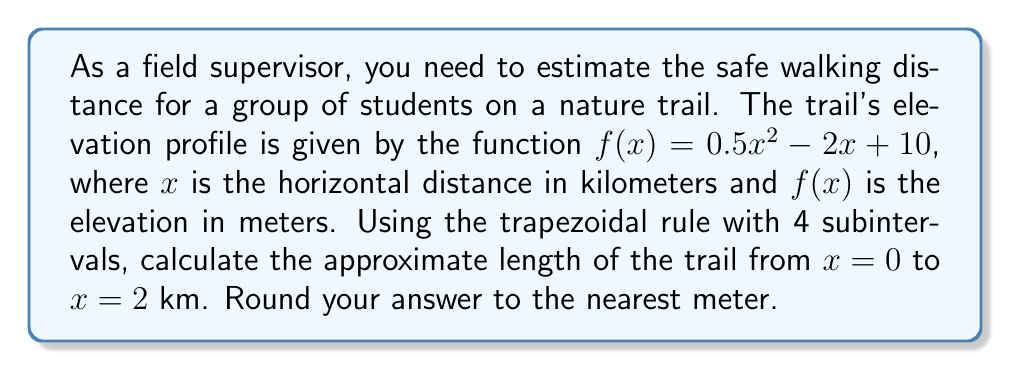Can you answer this question? To solve this problem, we'll use the trapezoidal rule for numerical integration to approximate the arc length of the trail. The steps are as follows:

1) The formula for arc length is:

   $$L = \int_a^b \sqrt{1 + [f'(x)]^2} dx$$

2) First, we need to find $f'(x)$:
   
   $$f'(x) = x - 2$$

3) Now, our integrand is:

   $$\sqrt{1 + (x - 2)^2}$$

4) We'll use the trapezoidal rule with 4 subintervals. The formula is:

   $$\int_a^b f(x)dx \approx \frac{h}{2}[f(x_0) + 2f(x_1) + 2f(x_2) + 2f(x_3) + f(x_4)]$$

   where $h = \frac{b-a}{n}$, and $n$ is the number of subintervals.

5) In our case, $a = 0$, $b = 2$, and $n = 4$. So, $h = \frac{2-0}{4} = 0.5$

6) We need to evaluate our integrand at $x = 0, 0.5, 1, 1.5,$ and $2$:

   $$x_0 = 0: \sqrt{1 + (-2)^2} = \sqrt{5}$$
   $$x_1 = 0.5: \sqrt{1 + (-1.5)^2} \approx 1.8028$$
   $$x_2 = 1: \sqrt{1 + (-1)^2} = \sqrt{2} \approx 1.4142$$
   $$x_3 = 1.5: \sqrt{1 + (-0.5)^2} \approx 1.1180$$
   $$x_4 = 2: \sqrt{1 + 0^2} = 1$$

7) Applying the trapezoidal rule:

   $$L \approx \frac{0.5}{2}[\sqrt{5} + 2(1.8028) + 2(1.4142) + 2(1.1180) + 1]$$
   $$\approx 0.25[2.2361 + 3.6056 + 2.8284 + 2.2360 + 1]$$
   $$\approx 0.25[11.9061]$$
   $$\approx 2.9765$$

8) Converting to meters: $2.9765 \times 1000 \approx 2976.5$ meters

9) Rounding to the nearest meter: 2977 meters
Answer: 2977 meters 